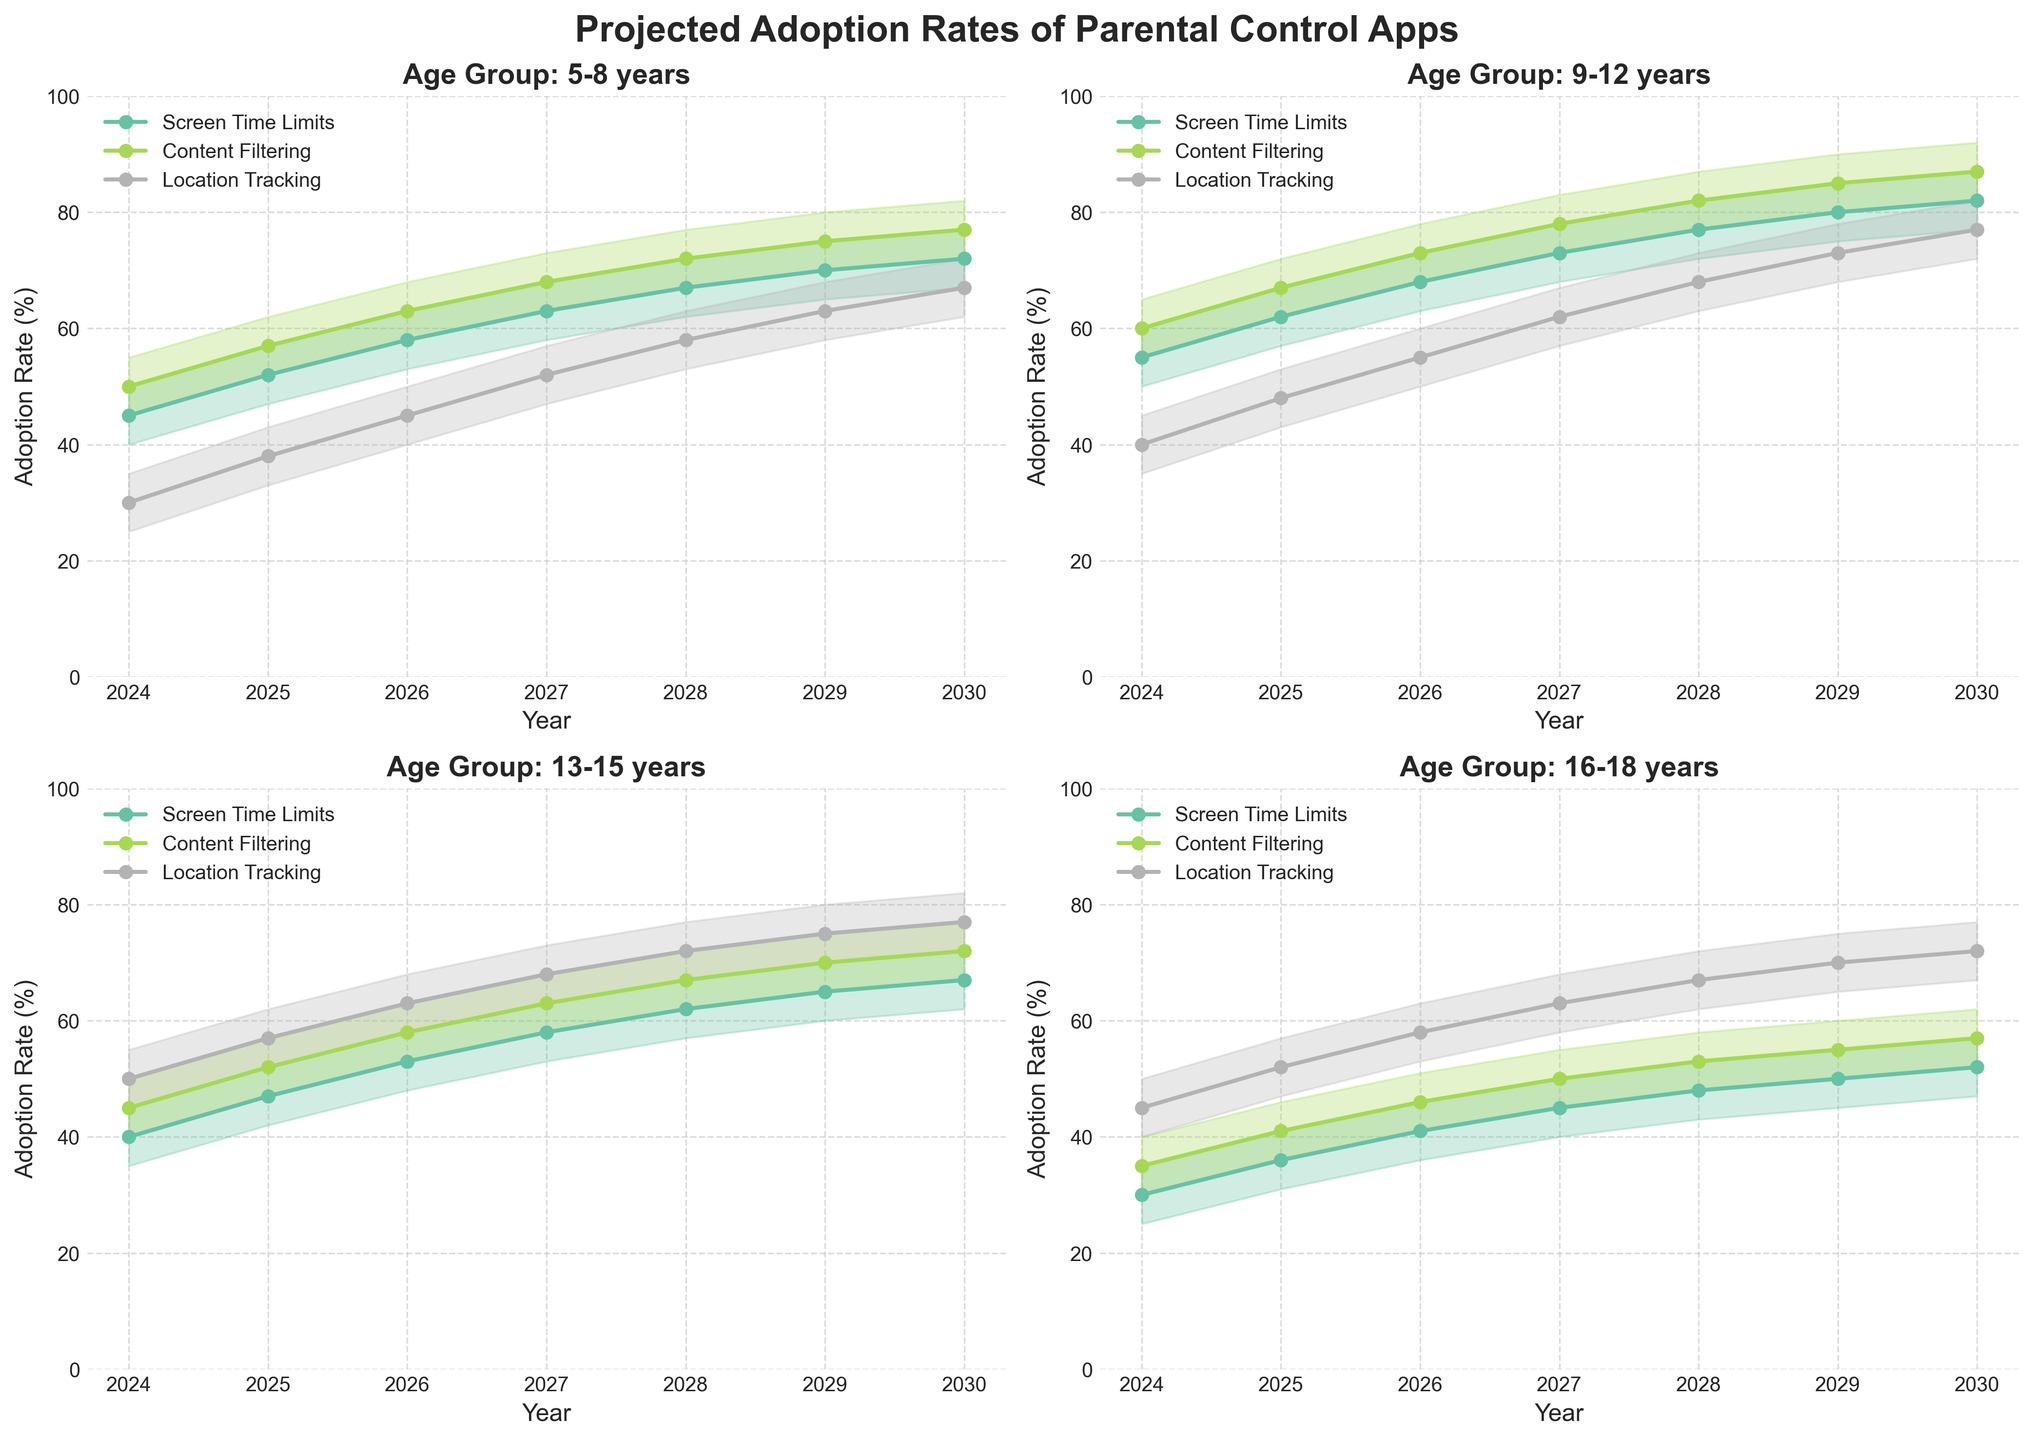What is the projected adoption rate for Screen Time Limits in the 9-12 years age group for the year 2025? To find the projected adoption rate for Screen Time Limits in the 9-12 years age group for 2025, look at the corresponding line in the plot labeled 'Screen Time Limits' for the 9-12 years subplot and read the 2025 value.
Answer: 62% How does the adoption rate of Content Filtering for ages 13-15 in 2027 compare to the adoption rate of Location Tracking for the same age group in the same year? To compare, find the adoption rates of Content Filtering and Location Tracking for the 13-15 years age group in 2027. Check the respective lines and read their values for 2027.
Answer: Content Filtering: 63%, Location Tracking: 68% Which feature has the highest projected adoption rate for the 16-18 age group in 2029? Look at the 16-18 years subplot and check the adoption rates for each feature in the year 2029. Identify which feature line peaks the highest.
Answer: Location Tracking What is the difference in adoption rates of Screen Time Limits between the 5-8 years and 16-18 years age groups in 2030? Subtract the adoption rate of Screen Time Limits for the 16-18 years group from that of the 5-8 years group for the year 2030.
Answer: 72% - 52% = 20% What is the overall trend of Content Filtering usage for all age groups from 2024 to 2030? Examine the lines representing Content Filtering in all subplots. Notice whether the lines generally increase, decrease, or stay constant.
Answer: Increasing Which age group shows the most significant increase in the adoption rate of Location Tracking from 2024 to 2030? Calculate the increase in adoption rate from 2024 to 2030 for each age group's Location Tracking line and compare the differences.
Answer: 5-8 years (from 30% to 67%) By how much does the adoption rate of Screen Time Limits in the 5-8 years group change from 2024 to 2027? Subtract the adoption rate of Screen Time Limits for the 5-8 years group in 2024 from the rate in 2027.
Answer: 63% - 45% = 18% In 2028, which age group has the highest adoption rate for Content Filtering? Look at the 2028 values for Content Filtering in each age group subplot and compare them.
Answer: 9-12 years What is the average projected adoption rate of Content Filtering for the 13-15 age group over the years 2024 to 2030? Add up the adoption rates for Content Filtering from 2024 to 2030 for the 13-15 years group, then divide the sum by the number of years.
Answer: (45 + 52 + 58 + 63 + 67 + 70 + 72) / 7 = 61% Which two features for the 9-12 years age group have the closest adoption rates in 2026? Compare the adoption rates of all features for the 9-12 years age group in 2026 and find the two with the smallest difference.
Answer: Screen Time Limits (68%) and Content Filtering (73%) 